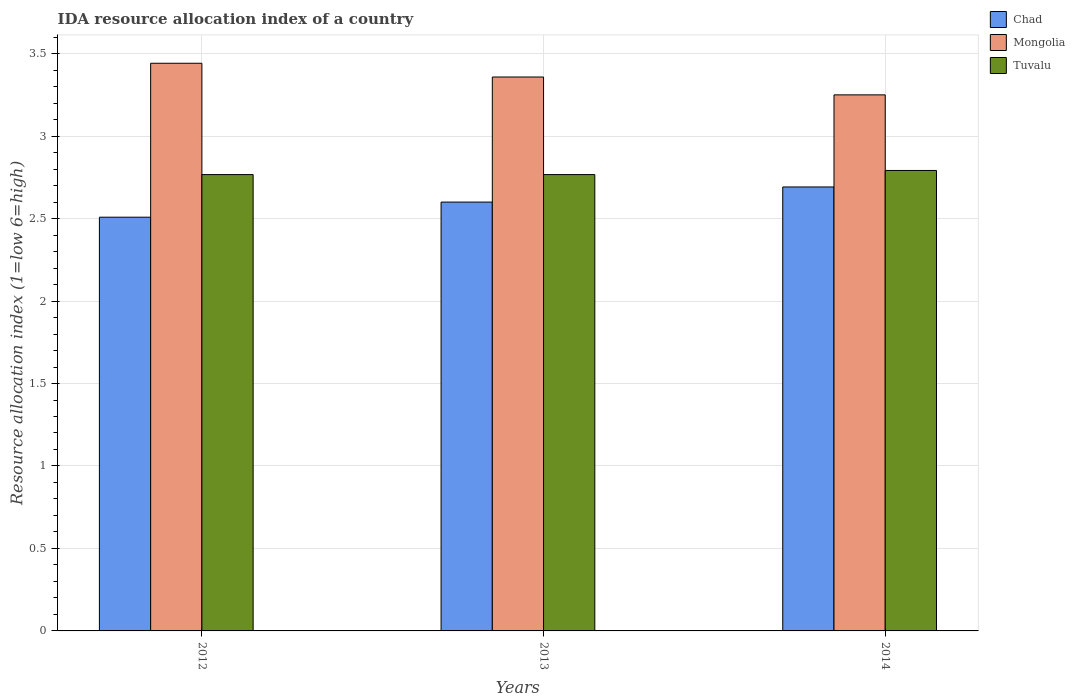What is the IDA resource allocation index in Tuvalu in 2013?
Your response must be concise. 2.77. Across all years, what is the maximum IDA resource allocation index in Tuvalu?
Ensure brevity in your answer.  2.79. Across all years, what is the minimum IDA resource allocation index in Tuvalu?
Your response must be concise. 2.77. What is the total IDA resource allocation index in Chad in the graph?
Provide a succinct answer. 7.8. What is the difference between the IDA resource allocation index in Mongolia in 2012 and that in 2014?
Make the answer very short. 0.19. What is the difference between the IDA resource allocation index in Mongolia in 2014 and the IDA resource allocation index in Tuvalu in 2012?
Your response must be concise. 0.48. What is the average IDA resource allocation index in Chad per year?
Your answer should be very brief. 2.6. In the year 2012, what is the difference between the IDA resource allocation index in Chad and IDA resource allocation index in Tuvalu?
Make the answer very short. -0.26. In how many years, is the IDA resource allocation index in Tuvalu greater than 2.7?
Provide a succinct answer. 3. What is the ratio of the IDA resource allocation index in Chad in 2013 to that in 2014?
Give a very brief answer. 0.97. What is the difference between the highest and the second highest IDA resource allocation index in Tuvalu?
Offer a very short reply. 0.03. What is the difference between the highest and the lowest IDA resource allocation index in Mongolia?
Your response must be concise. 0.19. In how many years, is the IDA resource allocation index in Chad greater than the average IDA resource allocation index in Chad taken over all years?
Keep it short and to the point. 1. Is the sum of the IDA resource allocation index in Tuvalu in 2012 and 2014 greater than the maximum IDA resource allocation index in Chad across all years?
Offer a terse response. Yes. What does the 2nd bar from the left in 2012 represents?
Make the answer very short. Mongolia. What does the 2nd bar from the right in 2014 represents?
Ensure brevity in your answer.  Mongolia. Is it the case that in every year, the sum of the IDA resource allocation index in Chad and IDA resource allocation index in Tuvalu is greater than the IDA resource allocation index in Mongolia?
Ensure brevity in your answer.  Yes. How many bars are there?
Your answer should be very brief. 9. How many years are there in the graph?
Give a very brief answer. 3. Does the graph contain any zero values?
Provide a succinct answer. No. How are the legend labels stacked?
Offer a very short reply. Vertical. What is the title of the graph?
Provide a succinct answer. IDA resource allocation index of a country. Does "Burkina Faso" appear as one of the legend labels in the graph?
Provide a succinct answer. No. What is the label or title of the X-axis?
Provide a succinct answer. Years. What is the label or title of the Y-axis?
Ensure brevity in your answer.  Resource allocation index (1=low 6=high). What is the Resource allocation index (1=low 6=high) of Chad in 2012?
Your answer should be compact. 2.51. What is the Resource allocation index (1=low 6=high) in Mongolia in 2012?
Your response must be concise. 3.44. What is the Resource allocation index (1=low 6=high) in Tuvalu in 2012?
Your answer should be very brief. 2.77. What is the Resource allocation index (1=low 6=high) of Mongolia in 2013?
Provide a short and direct response. 3.36. What is the Resource allocation index (1=low 6=high) of Tuvalu in 2013?
Your response must be concise. 2.77. What is the Resource allocation index (1=low 6=high) in Chad in 2014?
Make the answer very short. 2.69. What is the Resource allocation index (1=low 6=high) of Tuvalu in 2014?
Your response must be concise. 2.79. Across all years, what is the maximum Resource allocation index (1=low 6=high) in Chad?
Ensure brevity in your answer.  2.69. Across all years, what is the maximum Resource allocation index (1=low 6=high) in Mongolia?
Provide a succinct answer. 3.44. Across all years, what is the maximum Resource allocation index (1=low 6=high) in Tuvalu?
Keep it short and to the point. 2.79. Across all years, what is the minimum Resource allocation index (1=low 6=high) of Chad?
Offer a very short reply. 2.51. Across all years, what is the minimum Resource allocation index (1=low 6=high) in Mongolia?
Offer a terse response. 3.25. Across all years, what is the minimum Resource allocation index (1=low 6=high) in Tuvalu?
Keep it short and to the point. 2.77. What is the total Resource allocation index (1=low 6=high) of Chad in the graph?
Make the answer very short. 7.8. What is the total Resource allocation index (1=low 6=high) of Mongolia in the graph?
Make the answer very short. 10.05. What is the total Resource allocation index (1=low 6=high) in Tuvalu in the graph?
Give a very brief answer. 8.32. What is the difference between the Resource allocation index (1=low 6=high) in Chad in 2012 and that in 2013?
Provide a succinct answer. -0.09. What is the difference between the Resource allocation index (1=low 6=high) of Mongolia in 2012 and that in 2013?
Offer a very short reply. 0.08. What is the difference between the Resource allocation index (1=low 6=high) of Tuvalu in 2012 and that in 2013?
Your response must be concise. 0. What is the difference between the Resource allocation index (1=low 6=high) of Chad in 2012 and that in 2014?
Your answer should be compact. -0.18. What is the difference between the Resource allocation index (1=low 6=high) of Mongolia in 2012 and that in 2014?
Your response must be concise. 0.19. What is the difference between the Resource allocation index (1=low 6=high) in Tuvalu in 2012 and that in 2014?
Your answer should be very brief. -0.03. What is the difference between the Resource allocation index (1=low 6=high) of Chad in 2013 and that in 2014?
Your answer should be very brief. -0.09. What is the difference between the Resource allocation index (1=low 6=high) in Mongolia in 2013 and that in 2014?
Keep it short and to the point. 0.11. What is the difference between the Resource allocation index (1=low 6=high) of Tuvalu in 2013 and that in 2014?
Offer a very short reply. -0.03. What is the difference between the Resource allocation index (1=low 6=high) of Chad in 2012 and the Resource allocation index (1=low 6=high) of Mongolia in 2013?
Keep it short and to the point. -0.85. What is the difference between the Resource allocation index (1=low 6=high) in Chad in 2012 and the Resource allocation index (1=low 6=high) in Tuvalu in 2013?
Your answer should be compact. -0.26. What is the difference between the Resource allocation index (1=low 6=high) in Mongolia in 2012 and the Resource allocation index (1=low 6=high) in Tuvalu in 2013?
Provide a short and direct response. 0.68. What is the difference between the Resource allocation index (1=low 6=high) in Chad in 2012 and the Resource allocation index (1=low 6=high) in Mongolia in 2014?
Offer a very short reply. -0.74. What is the difference between the Resource allocation index (1=low 6=high) of Chad in 2012 and the Resource allocation index (1=low 6=high) of Tuvalu in 2014?
Provide a succinct answer. -0.28. What is the difference between the Resource allocation index (1=low 6=high) of Mongolia in 2012 and the Resource allocation index (1=low 6=high) of Tuvalu in 2014?
Make the answer very short. 0.65. What is the difference between the Resource allocation index (1=low 6=high) in Chad in 2013 and the Resource allocation index (1=low 6=high) in Mongolia in 2014?
Make the answer very short. -0.65. What is the difference between the Resource allocation index (1=low 6=high) in Chad in 2013 and the Resource allocation index (1=low 6=high) in Tuvalu in 2014?
Offer a terse response. -0.19. What is the difference between the Resource allocation index (1=low 6=high) of Mongolia in 2013 and the Resource allocation index (1=low 6=high) of Tuvalu in 2014?
Your answer should be very brief. 0.57. What is the average Resource allocation index (1=low 6=high) in Mongolia per year?
Your response must be concise. 3.35. What is the average Resource allocation index (1=low 6=high) in Tuvalu per year?
Your answer should be very brief. 2.77. In the year 2012, what is the difference between the Resource allocation index (1=low 6=high) of Chad and Resource allocation index (1=low 6=high) of Mongolia?
Offer a terse response. -0.93. In the year 2012, what is the difference between the Resource allocation index (1=low 6=high) in Chad and Resource allocation index (1=low 6=high) in Tuvalu?
Offer a terse response. -0.26. In the year 2012, what is the difference between the Resource allocation index (1=low 6=high) in Mongolia and Resource allocation index (1=low 6=high) in Tuvalu?
Offer a very short reply. 0.68. In the year 2013, what is the difference between the Resource allocation index (1=low 6=high) of Chad and Resource allocation index (1=low 6=high) of Mongolia?
Offer a terse response. -0.76. In the year 2013, what is the difference between the Resource allocation index (1=low 6=high) in Chad and Resource allocation index (1=low 6=high) in Tuvalu?
Provide a short and direct response. -0.17. In the year 2013, what is the difference between the Resource allocation index (1=low 6=high) in Mongolia and Resource allocation index (1=low 6=high) in Tuvalu?
Ensure brevity in your answer.  0.59. In the year 2014, what is the difference between the Resource allocation index (1=low 6=high) in Chad and Resource allocation index (1=low 6=high) in Mongolia?
Your answer should be very brief. -0.56. In the year 2014, what is the difference between the Resource allocation index (1=low 6=high) of Chad and Resource allocation index (1=low 6=high) of Tuvalu?
Provide a short and direct response. -0.1. In the year 2014, what is the difference between the Resource allocation index (1=low 6=high) in Mongolia and Resource allocation index (1=low 6=high) in Tuvalu?
Provide a short and direct response. 0.46. What is the ratio of the Resource allocation index (1=low 6=high) of Chad in 2012 to that in 2013?
Keep it short and to the point. 0.96. What is the ratio of the Resource allocation index (1=low 6=high) in Mongolia in 2012 to that in 2013?
Keep it short and to the point. 1.02. What is the ratio of the Resource allocation index (1=low 6=high) in Chad in 2012 to that in 2014?
Make the answer very short. 0.93. What is the ratio of the Resource allocation index (1=low 6=high) in Mongolia in 2012 to that in 2014?
Offer a terse response. 1.06. What is the ratio of the Resource allocation index (1=low 6=high) in Tuvalu in 2012 to that in 2014?
Keep it short and to the point. 0.99. What is the ratio of the Resource allocation index (1=low 6=high) in Chad in 2013 to that in 2014?
Your answer should be very brief. 0.97. What is the ratio of the Resource allocation index (1=low 6=high) of Mongolia in 2013 to that in 2014?
Your response must be concise. 1.03. What is the difference between the highest and the second highest Resource allocation index (1=low 6=high) of Chad?
Offer a terse response. 0.09. What is the difference between the highest and the second highest Resource allocation index (1=low 6=high) of Mongolia?
Ensure brevity in your answer.  0.08. What is the difference between the highest and the second highest Resource allocation index (1=low 6=high) in Tuvalu?
Offer a very short reply. 0.03. What is the difference between the highest and the lowest Resource allocation index (1=low 6=high) of Chad?
Give a very brief answer. 0.18. What is the difference between the highest and the lowest Resource allocation index (1=low 6=high) of Mongolia?
Ensure brevity in your answer.  0.19. What is the difference between the highest and the lowest Resource allocation index (1=low 6=high) in Tuvalu?
Make the answer very short. 0.03. 